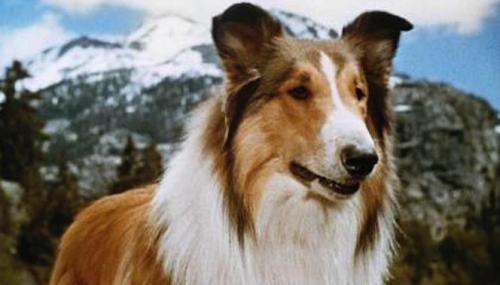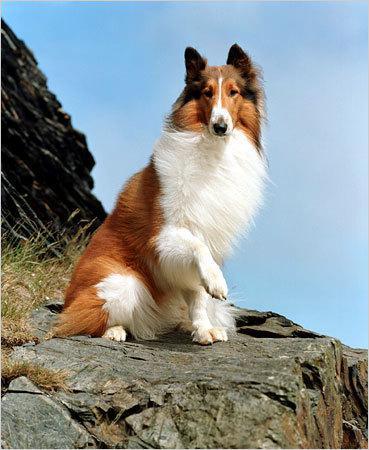The first image is the image on the left, the second image is the image on the right. Analyze the images presented: Is the assertion "The dog in the image on the right is not standing on grass." valid? Answer yes or no. Yes. 